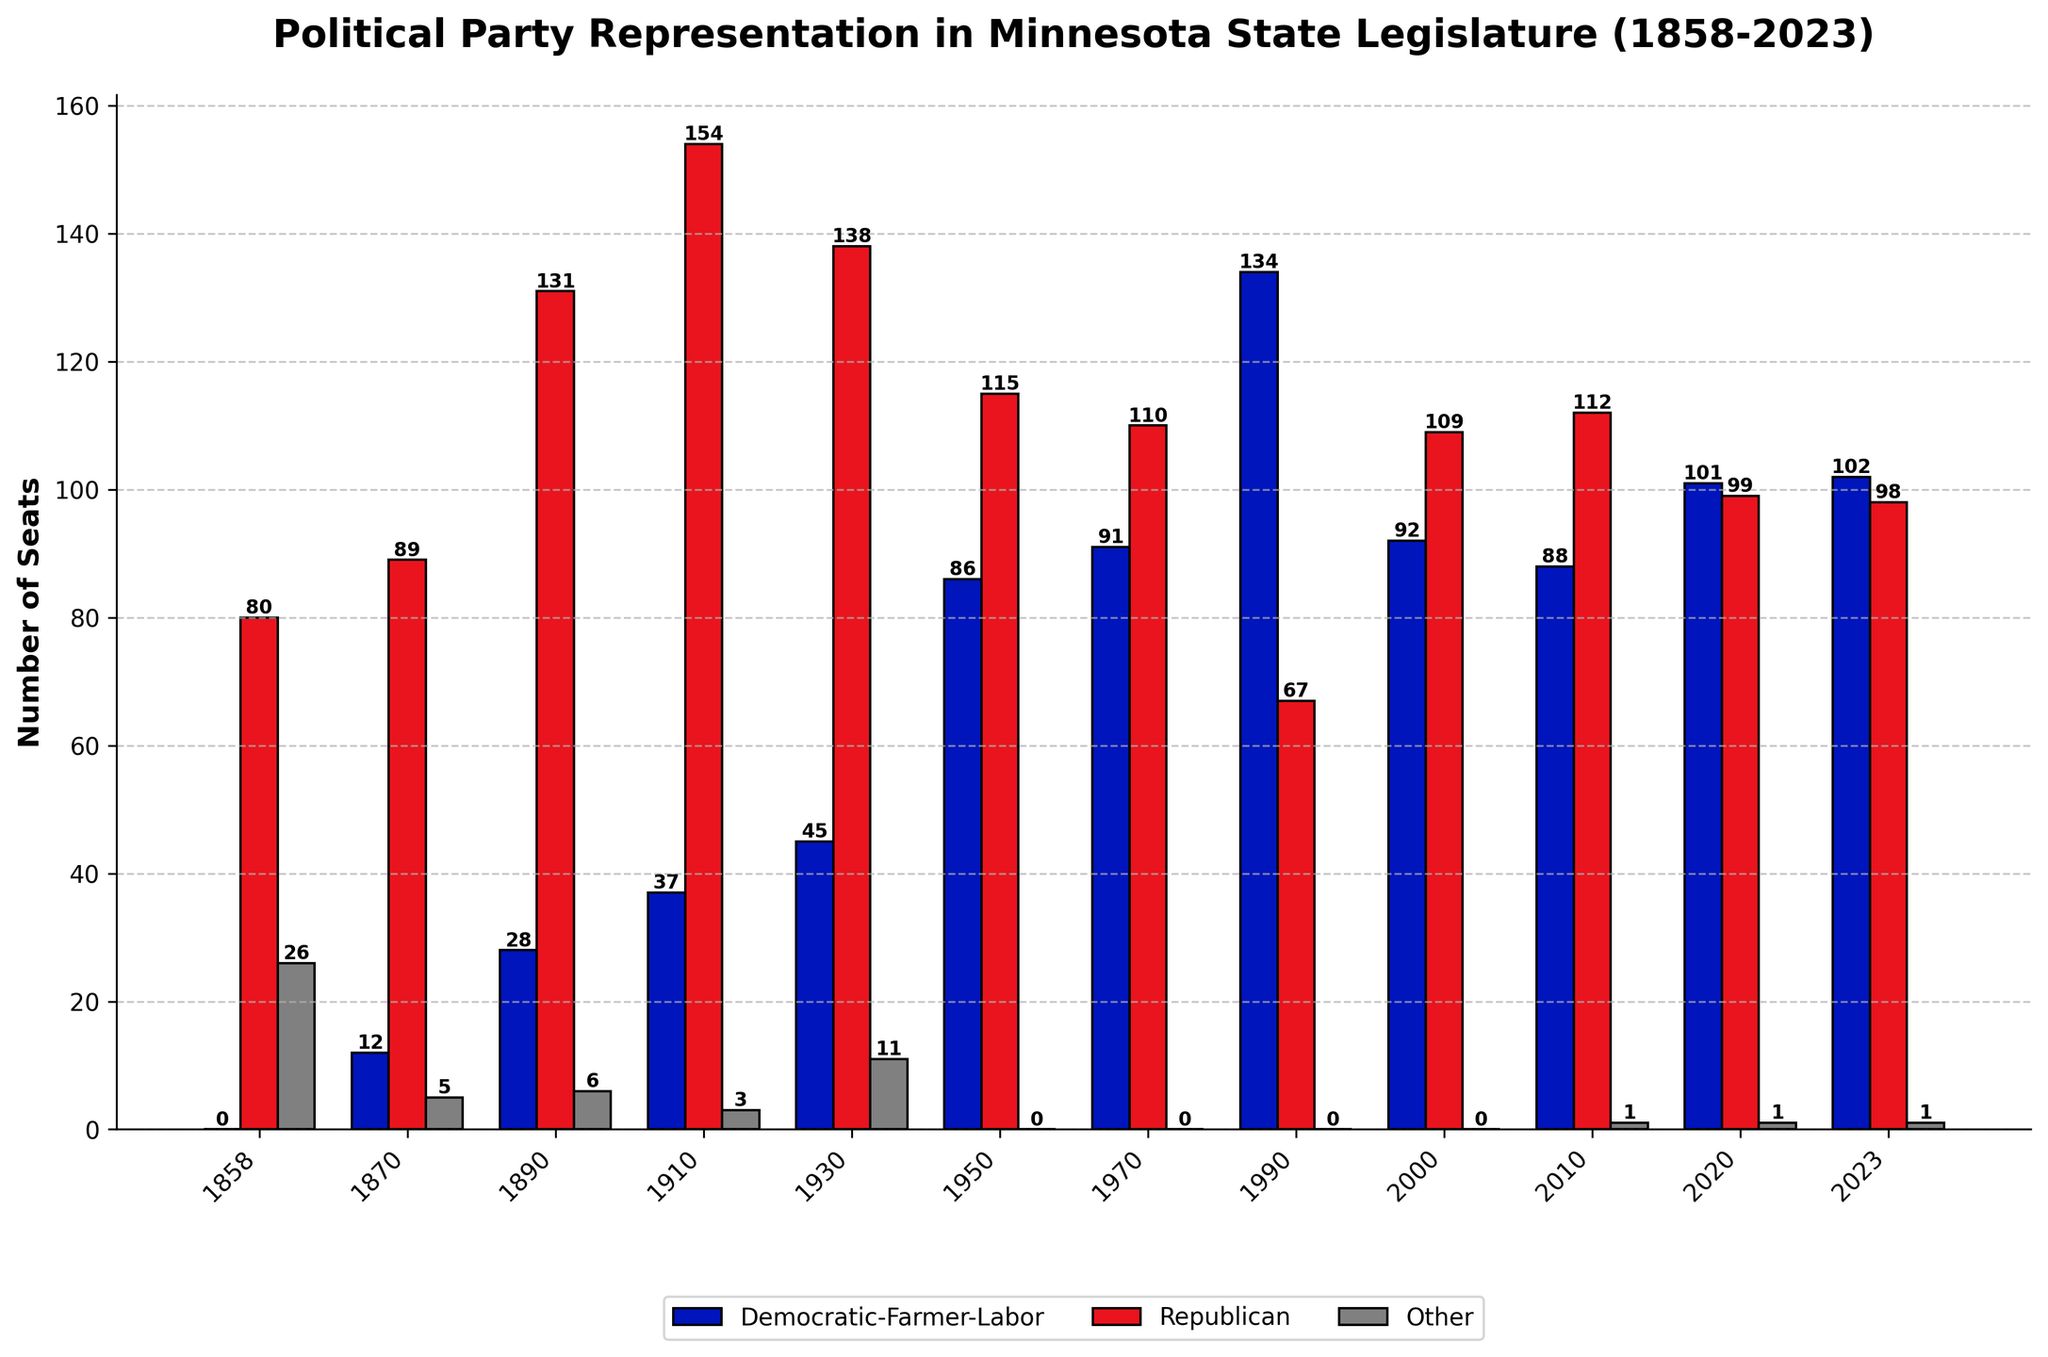What is the difference in the number of Republican and Democratic-Farmer-Labor seats in 1858? In 1858, the figure shows Republicans with 80 seats and Democratic-Farmer-Labor with 0 seats. The difference is calculated as 80 - 0.
Answer: 80 Which party had more seats in 1910 and by how many? In 1910, the Republicans had 154 seats, and the Democratic-Farmer-Labor had 37 seats. The Republicans had more seats by 154 - 37.
Answer: 117 In which years did the "Other" category have no representation? The "Other" category had 0 seats in 1950, 1970, 1990, and 2000 as shown on the chart.
Answer: 1950, 1970, 1990, 2000 What is the total number of seats represented in the 2023 figure? In 2023, the Democratic-Farmer-Labor had 102 seats, Republicans had 98, and Others had 1. The total is 102 + 98 + 1.
Answer: 201 How did the number of Democratic-Farmer-Labor seats change from 1990 to 2020? In 1990, Democratic-Farmer-Labor had 134 seats, and in 2020, they had 101 seats. The change is 101 - 134.
Answer: -33 Which year had the highest number of Democratic-Farmer-Labor seats? The figure shows the number of seats for Democratic-Farmer-Labor in various years. The highest number is 134 seats in 1990.
Answer: 1990 In 2020, was the number of Republican seats greater than the number of Democratic-Farmer-Labor seats? If so, by how much? In 2020, Democratic-Farmer-Labor had 101 seats and Republicans had 99 seats. The number of Republican seats is not greater than Democratic-Farmer-Labor seats.
Answer: No How does the number of total seats in 1890 compare to 2023? In 1890, the total seats are 28(D)_+_131(R)_+_6(O)_=_165. In 2023, the total is 102(D)_+_98(R)_+_1(O)_=_201. Compare 165 and 201.
Answer: 65 fewer in 1890 In how many years did Republicans have more than 100 seats? From the figure, Republicans had more than 100 seats in 1858, 1870, 1890, 1910, 1930, 1950, 1970, and 2010. Count these years.
Answer: 8 